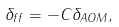<formula> <loc_0><loc_0><loc_500><loc_500>\delta _ { f f } = - C \delta _ { A O M } ,</formula> 